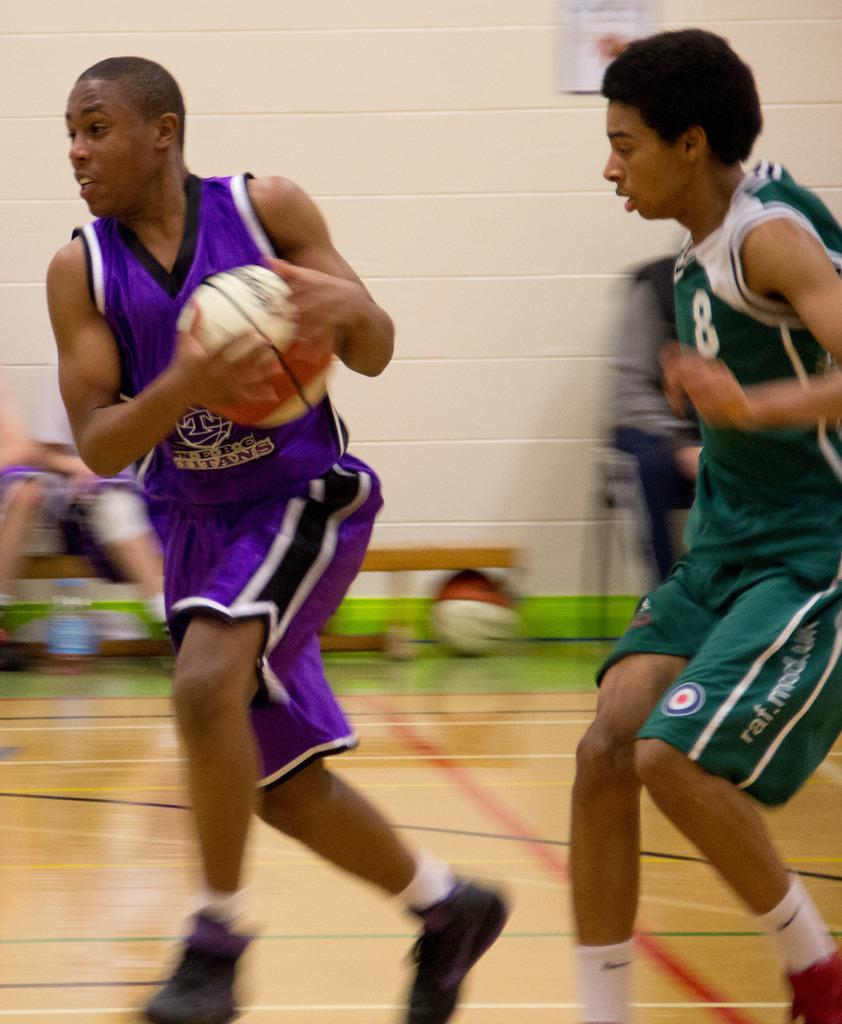Provide a one-sentence caption for the provided image. A man wearing a Titans jersey plays against number 8 in the green clothing. 